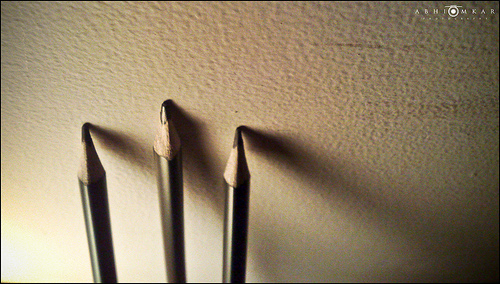<image>
Can you confirm if the tip is on the pen? No. The tip is not positioned on the pen. They may be near each other, but the tip is not supported by or resting on top of the pen. 